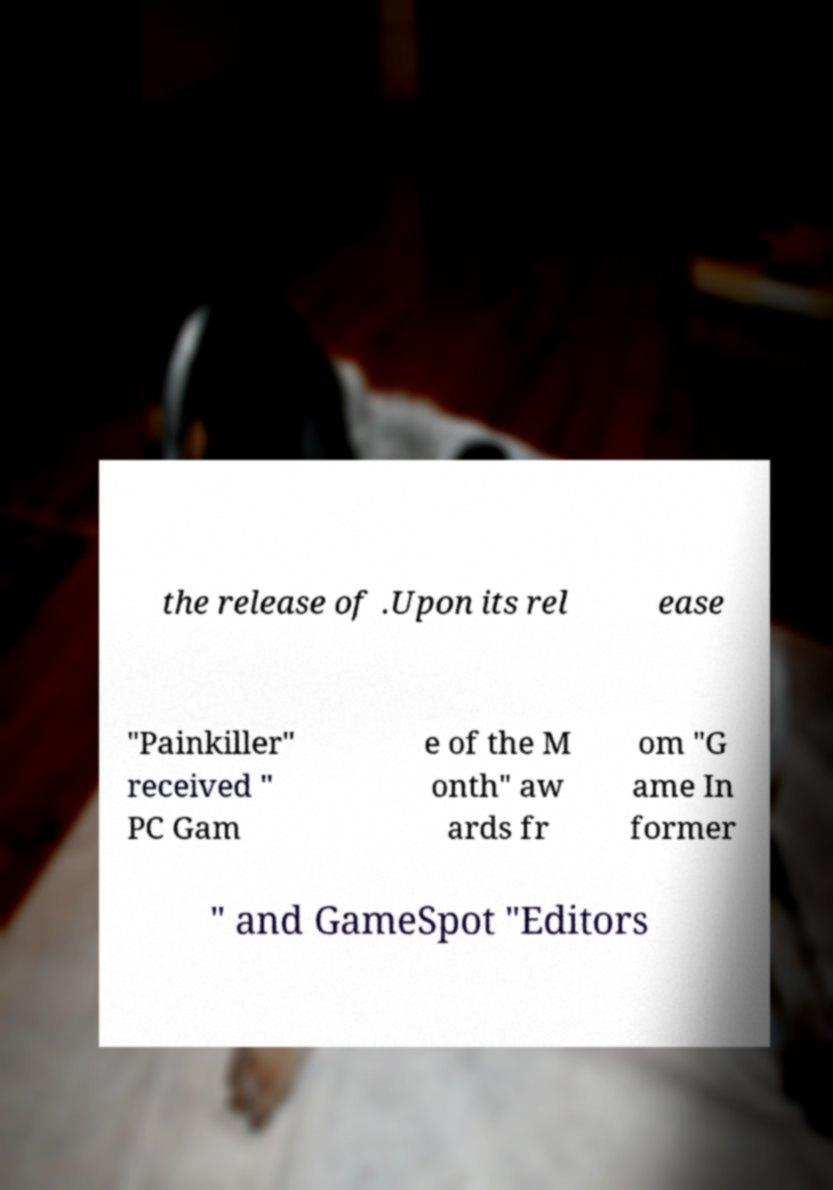Please identify and transcribe the text found in this image. the release of .Upon its rel ease "Painkiller" received " PC Gam e of the M onth" aw ards fr om "G ame In former " and GameSpot "Editors 